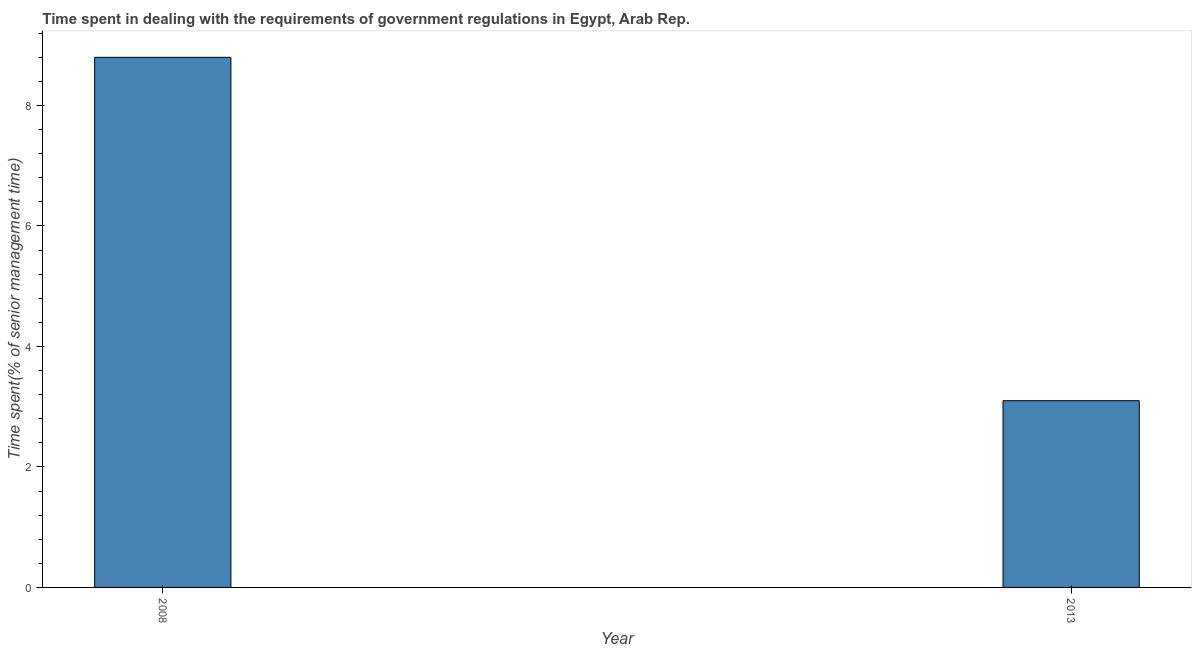What is the title of the graph?
Give a very brief answer. Time spent in dealing with the requirements of government regulations in Egypt, Arab Rep. What is the label or title of the X-axis?
Make the answer very short. Year. What is the label or title of the Y-axis?
Offer a very short reply. Time spent(% of senior management time). In which year was the time spent in dealing with government regulations maximum?
Your response must be concise. 2008. What is the difference between the time spent in dealing with government regulations in 2008 and 2013?
Offer a terse response. 5.7. What is the average time spent in dealing with government regulations per year?
Provide a short and direct response. 5.95. What is the median time spent in dealing with government regulations?
Offer a very short reply. 5.95. Do a majority of the years between 2008 and 2013 (inclusive) have time spent in dealing with government regulations greater than 6 %?
Provide a short and direct response. No. What is the ratio of the time spent in dealing with government regulations in 2008 to that in 2013?
Your answer should be very brief. 2.84. Are all the bars in the graph horizontal?
Offer a terse response. No. What is the difference between two consecutive major ticks on the Y-axis?
Offer a terse response. 2. What is the difference between the Time spent(% of senior management time) in 2008 and 2013?
Your answer should be compact. 5.7. What is the ratio of the Time spent(% of senior management time) in 2008 to that in 2013?
Provide a succinct answer. 2.84. 